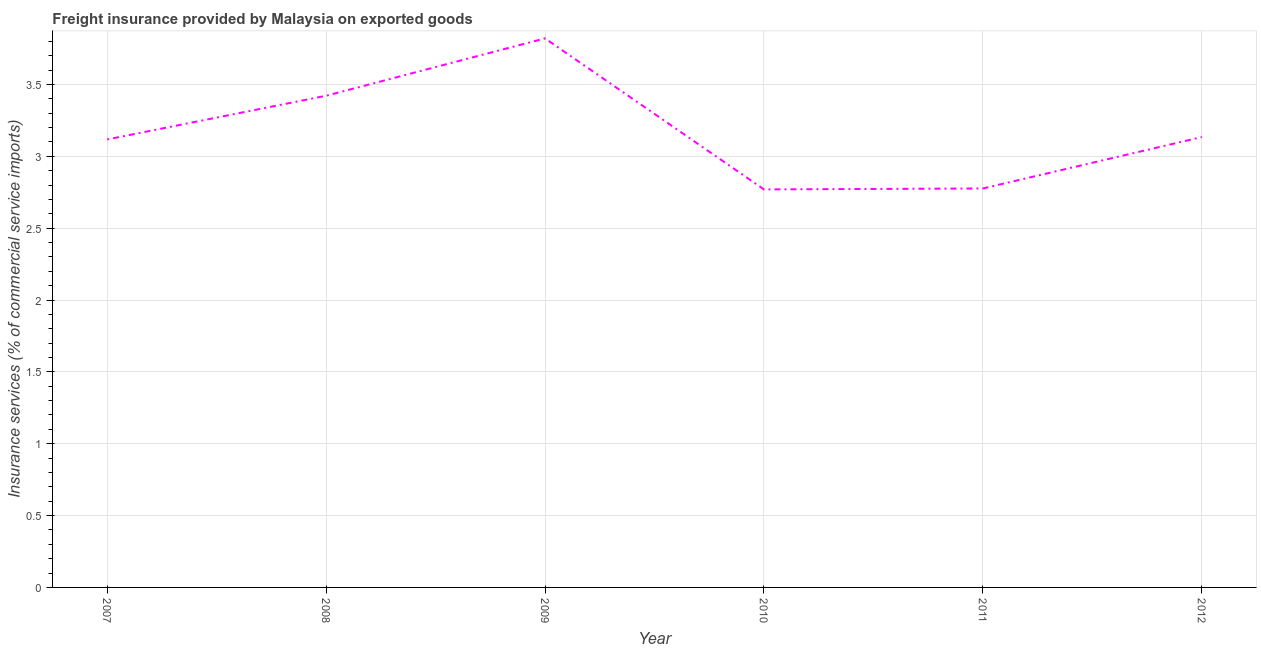What is the freight insurance in 2011?
Make the answer very short. 2.78. Across all years, what is the maximum freight insurance?
Ensure brevity in your answer.  3.82. Across all years, what is the minimum freight insurance?
Provide a succinct answer. 2.77. What is the sum of the freight insurance?
Your response must be concise. 19.04. What is the difference between the freight insurance in 2007 and 2012?
Make the answer very short. -0.02. What is the average freight insurance per year?
Your response must be concise. 3.17. What is the median freight insurance?
Your answer should be very brief. 3.13. In how many years, is the freight insurance greater than 1.9 %?
Your answer should be compact. 6. What is the ratio of the freight insurance in 2009 to that in 2012?
Offer a terse response. 1.22. What is the difference between the highest and the second highest freight insurance?
Provide a short and direct response. 0.4. What is the difference between the highest and the lowest freight insurance?
Your answer should be very brief. 1.05. How many lines are there?
Keep it short and to the point. 1. How many years are there in the graph?
Provide a short and direct response. 6. What is the difference between two consecutive major ticks on the Y-axis?
Provide a short and direct response. 0.5. What is the title of the graph?
Ensure brevity in your answer.  Freight insurance provided by Malaysia on exported goods . What is the label or title of the Y-axis?
Make the answer very short. Insurance services (% of commercial service imports). What is the Insurance services (% of commercial service imports) of 2007?
Offer a very short reply. 3.12. What is the Insurance services (% of commercial service imports) in 2008?
Ensure brevity in your answer.  3.42. What is the Insurance services (% of commercial service imports) in 2009?
Give a very brief answer. 3.82. What is the Insurance services (% of commercial service imports) of 2010?
Make the answer very short. 2.77. What is the Insurance services (% of commercial service imports) in 2011?
Ensure brevity in your answer.  2.78. What is the Insurance services (% of commercial service imports) in 2012?
Give a very brief answer. 3.13. What is the difference between the Insurance services (% of commercial service imports) in 2007 and 2008?
Your answer should be very brief. -0.3. What is the difference between the Insurance services (% of commercial service imports) in 2007 and 2009?
Ensure brevity in your answer.  -0.7. What is the difference between the Insurance services (% of commercial service imports) in 2007 and 2010?
Keep it short and to the point. 0.35. What is the difference between the Insurance services (% of commercial service imports) in 2007 and 2011?
Provide a succinct answer. 0.34. What is the difference between the Insurance services (% of commercial service imports) in 2007 and 2012?
Give a very brief answer. -0.02. What is the difference between the Insurance services (% of commercial service imports) in 2008 and 2009?
Provide a succinct answer. -0.4. What is the difference between the Insurance services (% of commercial service imports) in 2008 and 2010?
Offer a very short reply. 0.65. What is the difference between the Insurance services (% of commercial service imports) in 2008 and 2011?
Your response must be concise. 0.65. What is the difference between the Insurance services (% of commercial service imports) in 2008 and 2012?
Your answer should be compact. 0.29. What is the difference between the Insurance services (% of commercial service imports) in 2009 and 2010?
Provide a succinct answer. 1.05. What is the difference between the Insurance services (% of commercial service imports) in 2009 and 2011?
Keep it short and to the point. 1.04. What is the difference between the Insurance services (% of commercial service imports) in 2009 and 2012?
Your answer should be very brief. 0.69. What is the difference between the Insurance services (% of commercial service imports) in 2010 and 2011?
Provide a succinct answer. -0.01. What is the difference between the Insurance services (% of commercial service imports) in 2010 and 2012?
Provide a short and direct response. -0.36. What is the difference between the Insurance services (% of commercial service imports) in 2011 and 2012?
Offer a very short reply. -0.36. What is the ratio of the Insurance services (% of commercial service imports) in 2007 to that in 2008?
Give a very brief answer. 0.91. What is the ratio of the Insurance services (% of commercial service imports) in 2007 to that in 2009?
Offer a terse response. 0.82. What is the ratio of the Insurance services (% of commercial service imports) in 2007 to that in 2010?
Provide a short and direct response. 1.13. What is the ratio of the Insurance services (% of commercial service imports) in 2007 to that in 2011?
Provide a short and direct response. 1.12. What is the ratio of the Insurance services (% of commercial service imports) in 2007 to that in 2012?
Keep it short and to the point. 0.99. What is the ratio of the Insurance services (% of commercial service imports) in 2008 to that in 2009?
Offer a terse response. 0.9. What is the ratio of the Insurance services (% of commercial service imports) in 2008 to that in 2010?
Provide a short and direct response. 1.24. What is the ratio of the Insurance services (% of commercial service imports) in 2008 to that in 2011?
Provide a short and direct response. 1.23. What is the ratio of the Insurance services (% of commercial service imports) in 2008 to that in 2012?
Provide a short and direct response. 1.09. What is the ratio of the Insurance services (% of commercial service imports) in 2009 to that in 2010?
Ensure brevity in your answer.  1.38. What is the ratio of the Insurance services (% of commercial service imports) in 2009 to that in 2011?
Your response must be concise. 1.38. What is the ratio of the Insurance services (% of commercial service imports) in 2009 to that in 2012?
Provide a succinct answer. 1.22. What is the ratio of the Insurance services (% of commercial service imports) in 2010 to that in 2012?
Keep it short and to the point. 0.88. What is the ratio of the Insurance services (% of commercial service imports) in 2011 to that in 2012?
Offer a terse response. 0.89. 